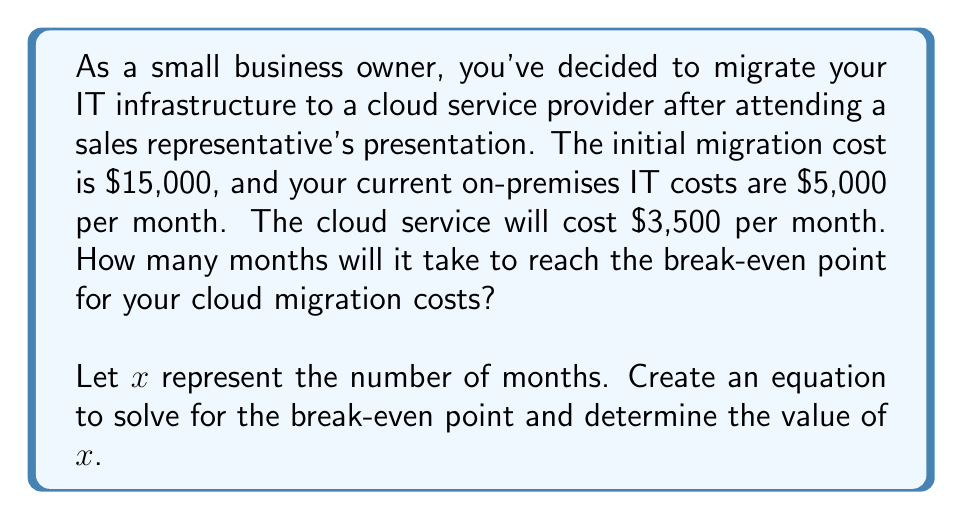Help me with this question. To solve this problem, we need to set up an equation that compares the total costs of the current on-premises system with the total costs of the cloud migration over time.

1. Let's define our variables:
   $x$ = number of months
   
2. Current on-premises costs over $x$ months:
   $5,000x$

3. Cloud migration costs over $x$ months:
   Initial migration cost + Monthly cloud service cost
   $15,000 + 3,500x$

4. At the break-even point, these two costs are equal:
   $5,000x = 15,000 + 3,500x$

5. Solve the equation:
   $5,000x = 15,000 + 3,500x$
   $5,000x - 3,500x = 15,000$
   $1,500x = 15,000$

6. Divide both sides by 1,500:
   $x = \frac{15,000}{1,500} = 10$

Therefore, it will take 10 months to reach the break-even point for the cloud migration costs.

To verify:
- On-premises costs after 10 months: $5,000 \times 10 = 50,000$
- Cloud costs after 10 months: $15,000 + (3,500 \times 10) = 50,000$

Both costs are equal at 10 months, confirming the break-even point.
Answer: The break-even point for cloud migration costs will be reached after 10 months. 